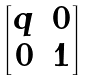Convert formula to latex. <formula><loc_0><loc_0><loc_500><loc_500>\begin{bmatrix} q & 0 \\ 0 & 1 \end{bmatrix}</formula> 